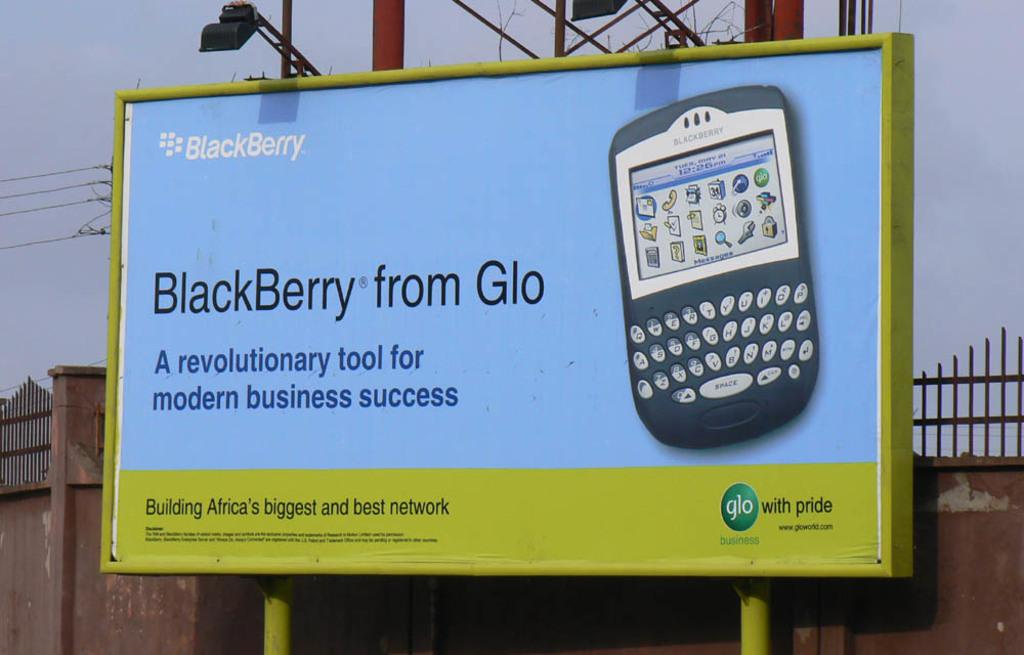What is the main object in the image? There is a hoarding in the image. What can be found on the hoarding? The hoarding contains text and an image of a mobile. What is visible in the background of the image? There is a wall with fencing in the background of the image. What else can be seen in the image? There are poles with lights in the image. What type of riddle is being solved by the oven in the image? There is no oven present in the image, so it's not possible to determine if a riddle is being solved. 